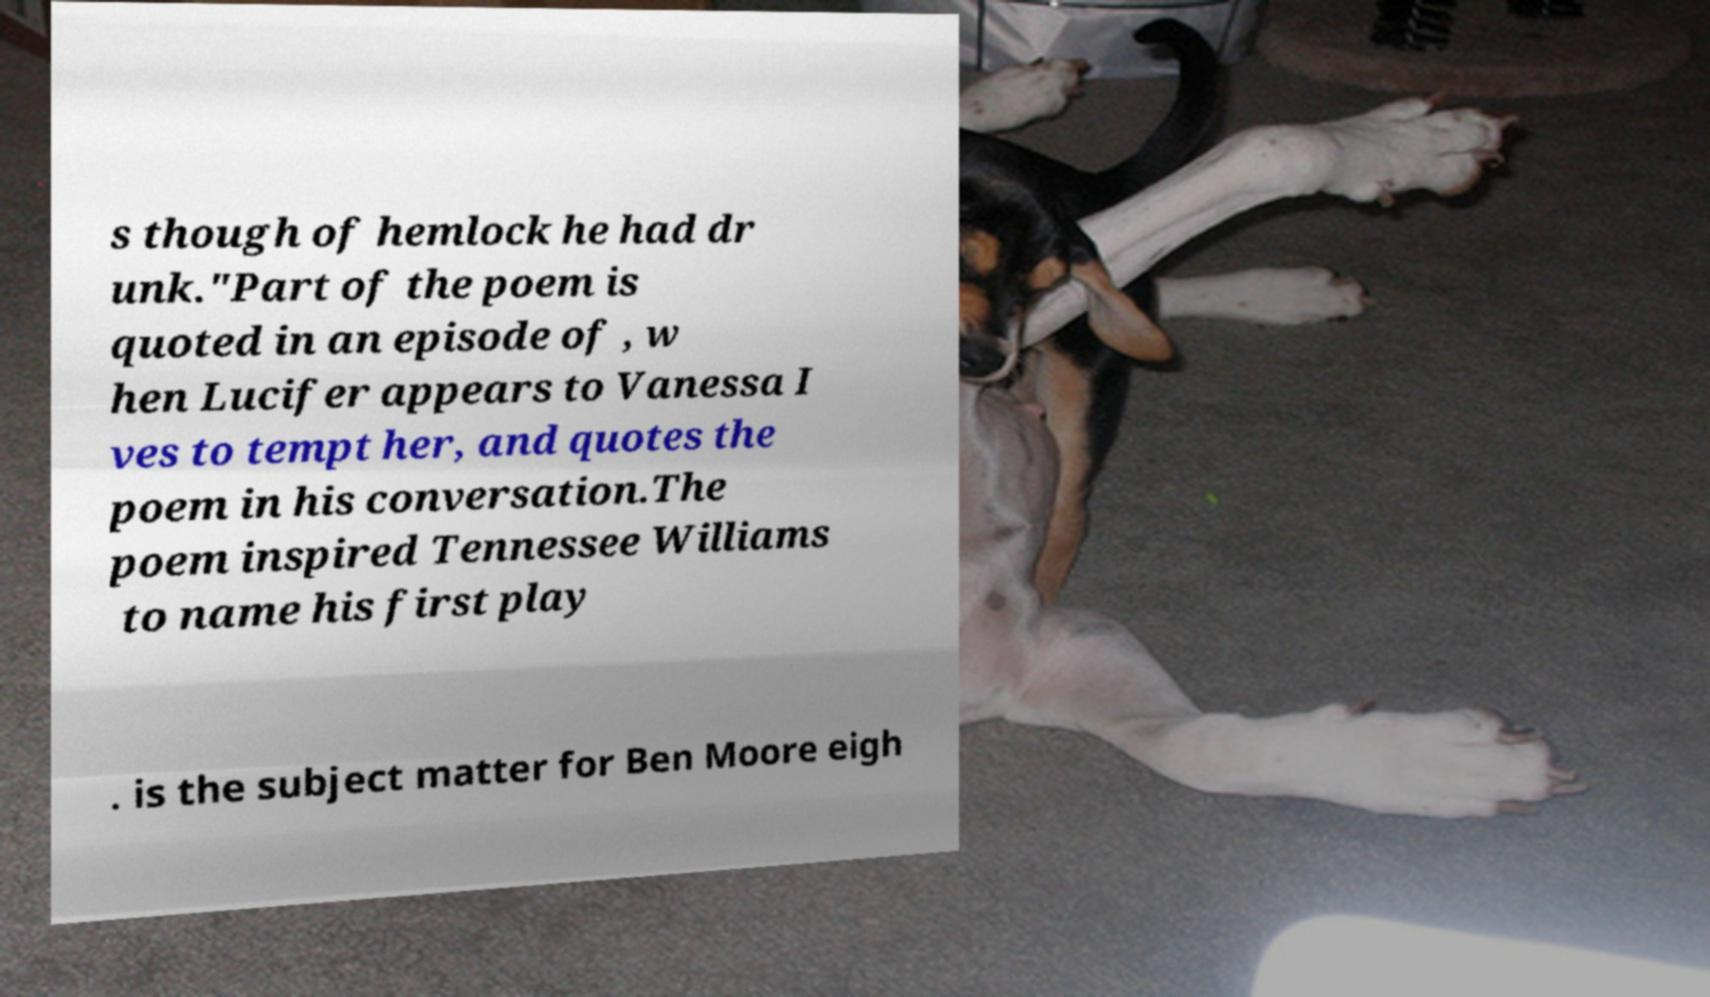Please read and relay the text visible in this image. What does it say? s though of hemlock he had dr unk."Part of the poem is quoted in an episode of , w hen Lucifer appears to Vanessa I ves to tempt her, and quotes the poem in his conversation.The poem inspired Tennessee Williams to name his first play . is the subject matter for Ben Moore eigh 